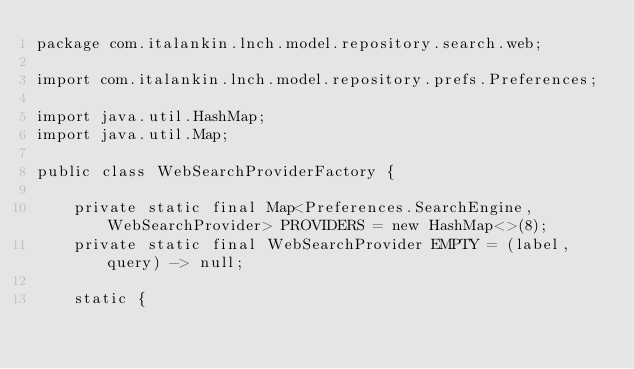Convert code to text. <code><loc_0><loc_0><loc_500><loc_500><_Java_>package com.italankin.lnch.model.repository.search.web;

import com.italankin.lnch.model.repository.prefs.Preferences;

import java.util.HashMap;
import java.util.Map;

public class WebSearchProviderFactory {

    private static final Map<Preferences.SearchEngine, WebSearchProvider> PROVIDERS = new HashMap<>(8);
    private static final WebSearchProvider EMPTY = (label, query) -> null;

    static {</code> 